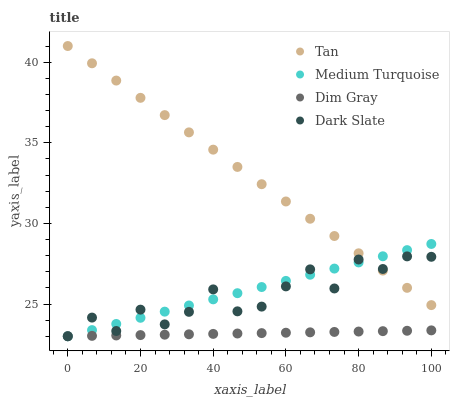Does Dim Gray have the minimum area under the curve?
Answer yes or no. Yes. Does Tan have the maximum area under the curve?
Answer yes or no. Yes. Does Tan have the minimum area under the curve?
Answer yes or no. No. Does Dim Gray have the maximum area under the curve?
Answer yes or no. No. Is Dim Gray the smoothest?
Answer yes or no. Yes. Is Dark Slate the roughest?
Answer yes or no. Yes. Is Tan the smoothest?
Answer yes or no. No. Is Tan the roughest?
Answer yes or no. No. Does Dark Slate have the lowest value?
Answer yes or no. Yes. Does Tan have the lowest value?
Answer yes or no. No. Does Tan have the highest value?
Answer yes or no. Yes. Does Dim Gray have the highest value?
Answer yes or no. No. Is Dim Gray less than Tan?
Answer yes or no. Yes. Is Tan greater than Dim Gray?
Answer yes or no. Yes. Does Dark Slate intersect Medium Turquoise?
Answer yes or no. Yes. Is Dark Slate less than Medium Turquoise?
Answer yes or no. No. Is Dark Slate greater than Medium Turquoise?
Answer yes or no. No. Does Dim Gray intersect Tan?
Answer yes or no. No. 